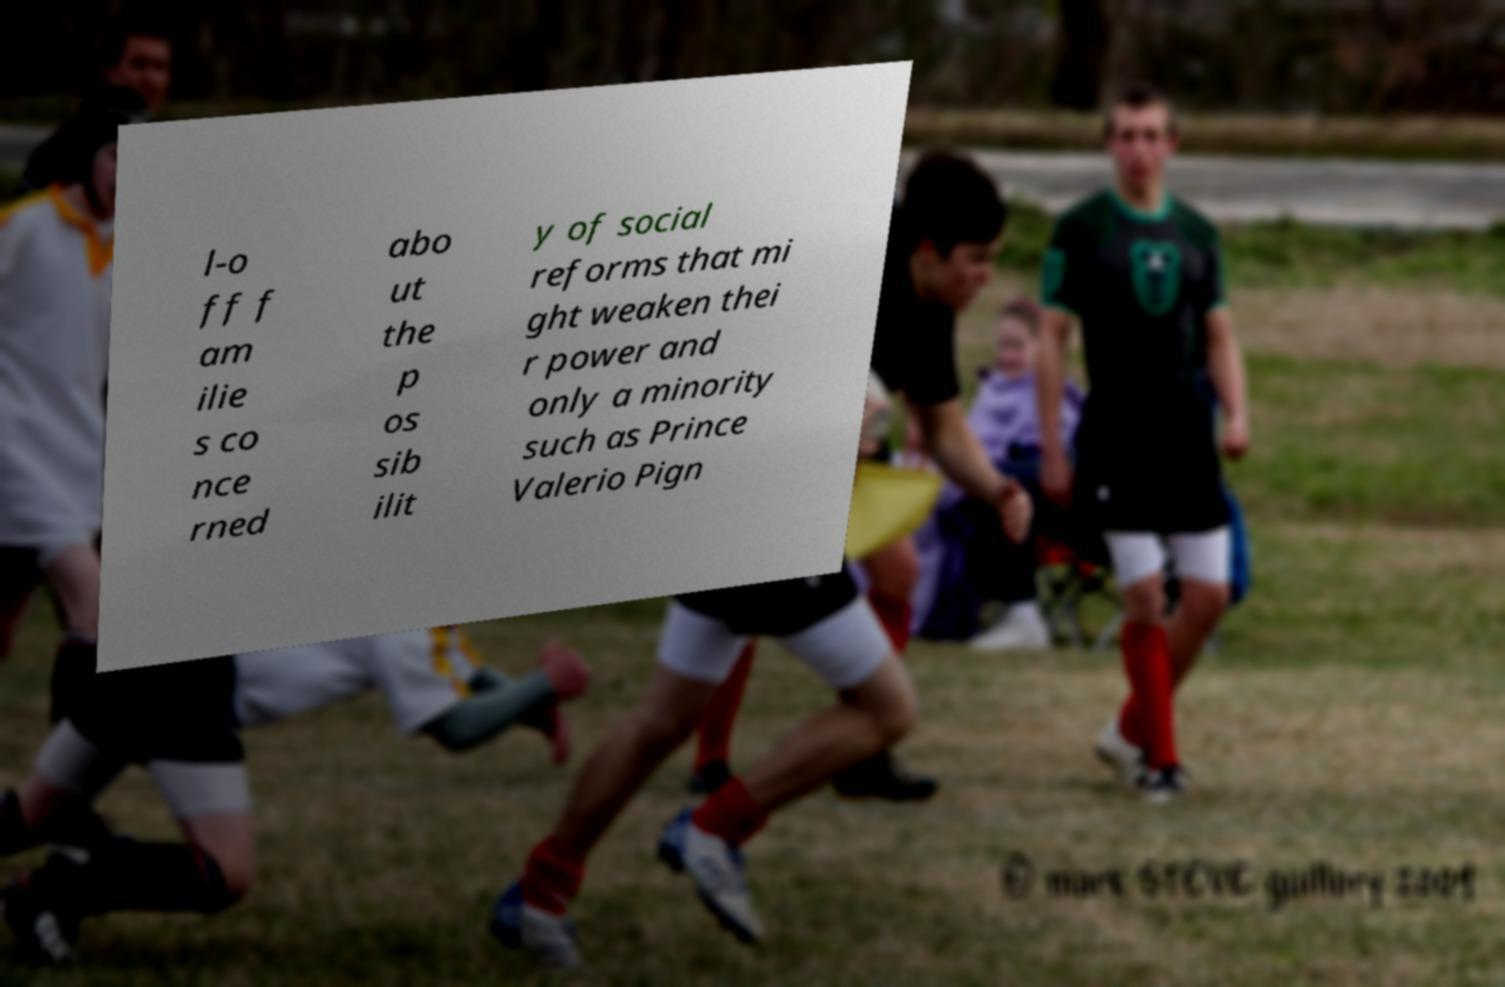Please read and relay the text visible in this image. What does it say? l-o ff f am ilie s co nce rned abo ut the p os sib ilit y of social reforms that mi ght weaken thei r power and only a minority such as Prince Valerio Pign 